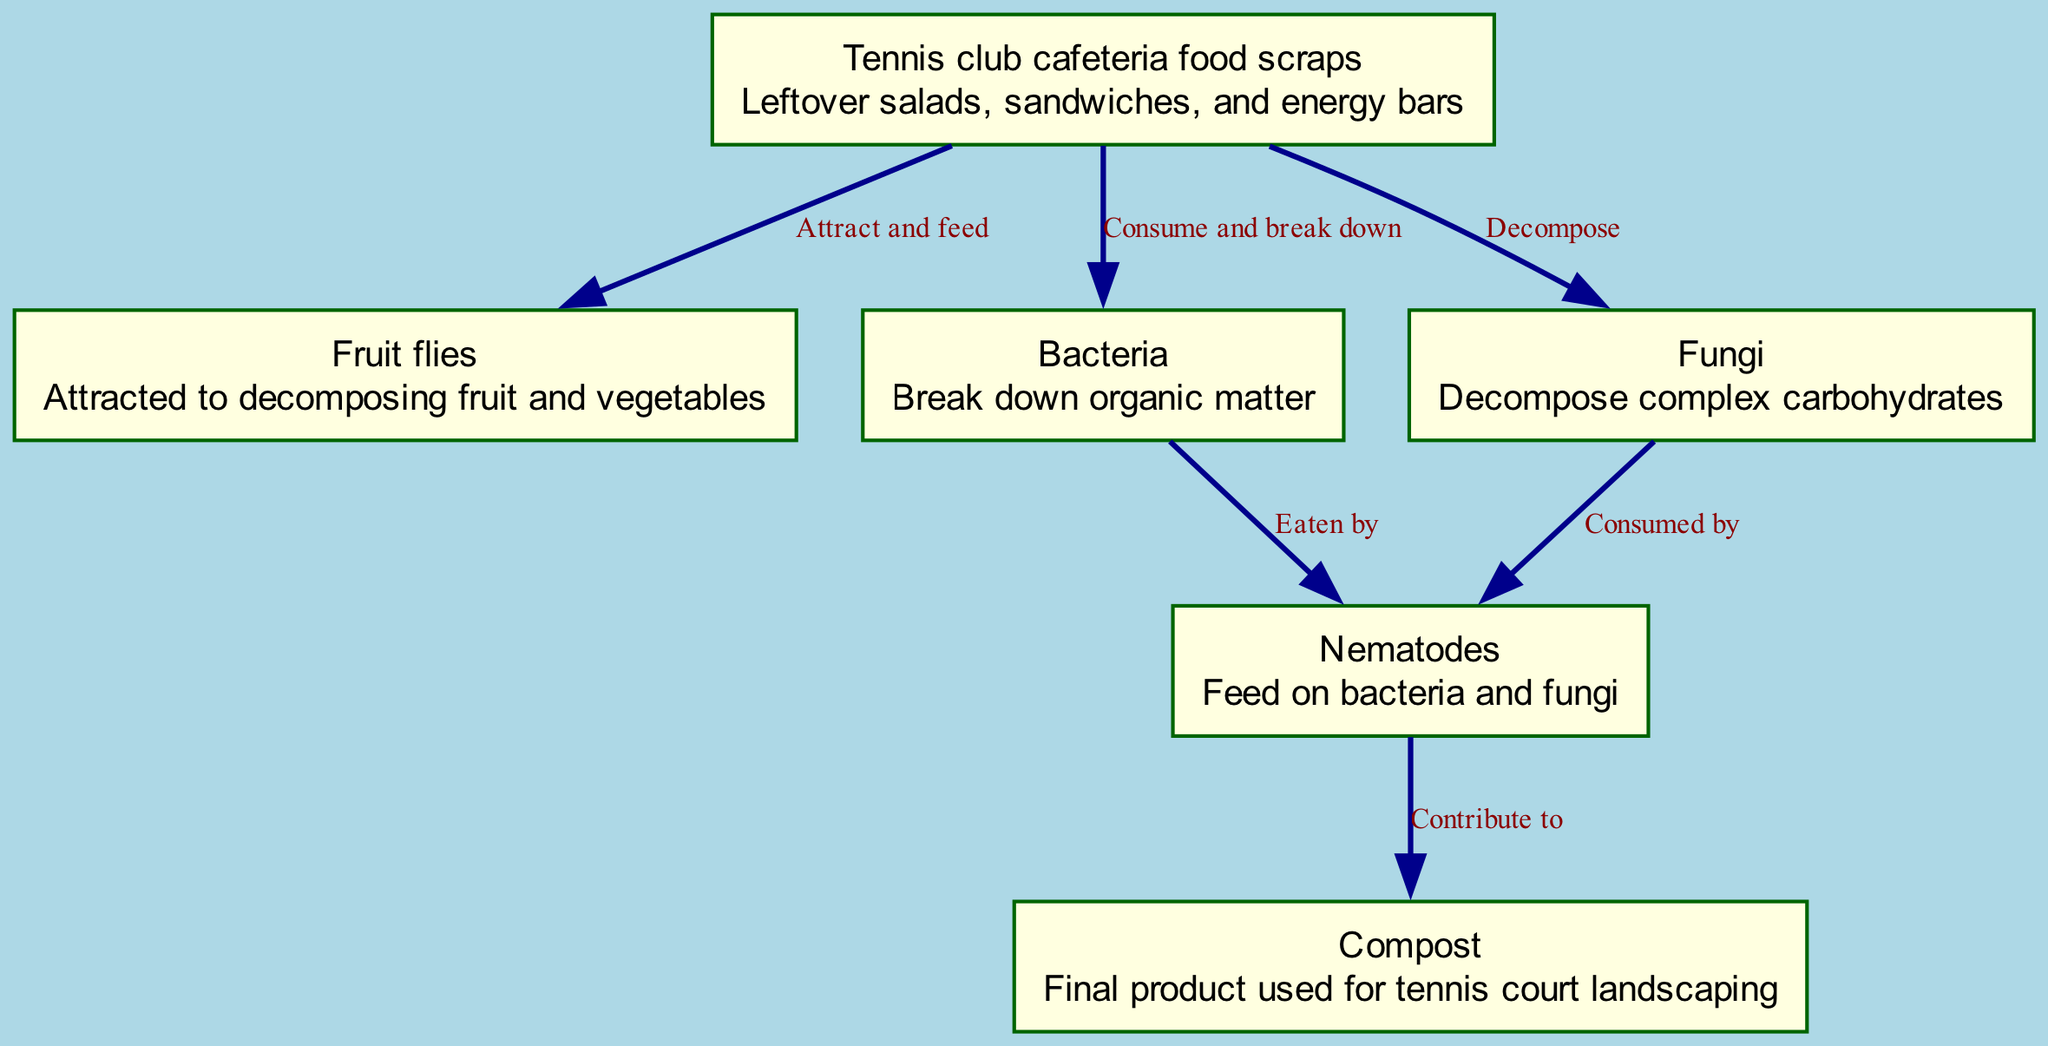What is the first element in the food chain? The first element in the food chain is the starting point, which is clearly labeled in the diagram as "Tennis club cafeteria food scraps".
Answer: Tennis club cafeteria food scraps How many connections are there in total? By counting the connections depicted in the diagram, we find that there are six arrows showing relationships between different elements.
Answer: 6 Which organism is attracted to the food scraps? The diagram indicates a direct relationship where "Fruit flies" are noted to be attracted to and feed on the "Tennis club cafeteria food scraps".
Answer: Fruit flies What do bacteria consume? According to the diagram, the bacteria specifically consume the "Tennis club cafeteria food scraps", indicating they break down this organic matter.
Answer: Tennis club cafeteria food scraps Which organisms are served as food for nematodes? The diagram shows arrows pointing towards "Nematodes" from both "Bacteria" and "Fungi", meaning nematodes feed on these two microorganisms.
Answer: Bacteria and Fungi What is the final product of the decomposition process? The diagram illustrates that after the decomposition process, the final output where the organic waste is transformed is labeled as "Compost".
Answer: Compost Which organism contributes directly to compost? The diagram specifies that "Nematodes" are involved in contributing to the final product, which is "Compost".
Answer: Nematodes What describes the relationship between fungi and nematodes? The diagram suggests a consumption relationship in which "Fungi" is consumed by "Nematodes", signifying a direct predator-prey interaction.
Answer: Consumed by What do fungi decompose? The diagram clearly labels the function of fungi as decomposing "complex carbohydrates", indicating their specific role in the decomposition process.
Answer: Complex carbohydrates 